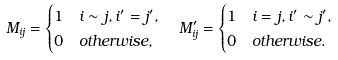Convert formula to latex. <formula><loc_0><loc_0><loc_500><loc_500>M _ { i j } & = \begin{cases} 1 & i \sim j , i ^ { \prime } = j ^ { \prime } , \\ 0 & o t h e r w i s e , \end{cases} \quad M ^ { \prime } _ { i j } = \begin{cases} 1 & i = j , i ^ { \prime } \sim j ^ { \prime } , \\ 0 & o t h e r w i s e . \end{cases}</formula> 